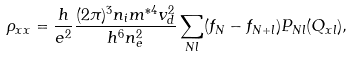<formula> <loc_0><loc_0><loc_500><loc_500>\rho _ { x x } = \frac { h } { e ^ { 2 } } \frac { ( 2 \pi ) ^ { 3 } n _ { i } m ^ { \ast 4 } v _ { d } ^ { 2 } } { h ^ { 6 } n _ { e } ^ { 2 } } \sum _ { N l } ( f _ { N } - f _ { N + l } ) P _ { N l } ( Q _ { x l } ) ,</formula> 